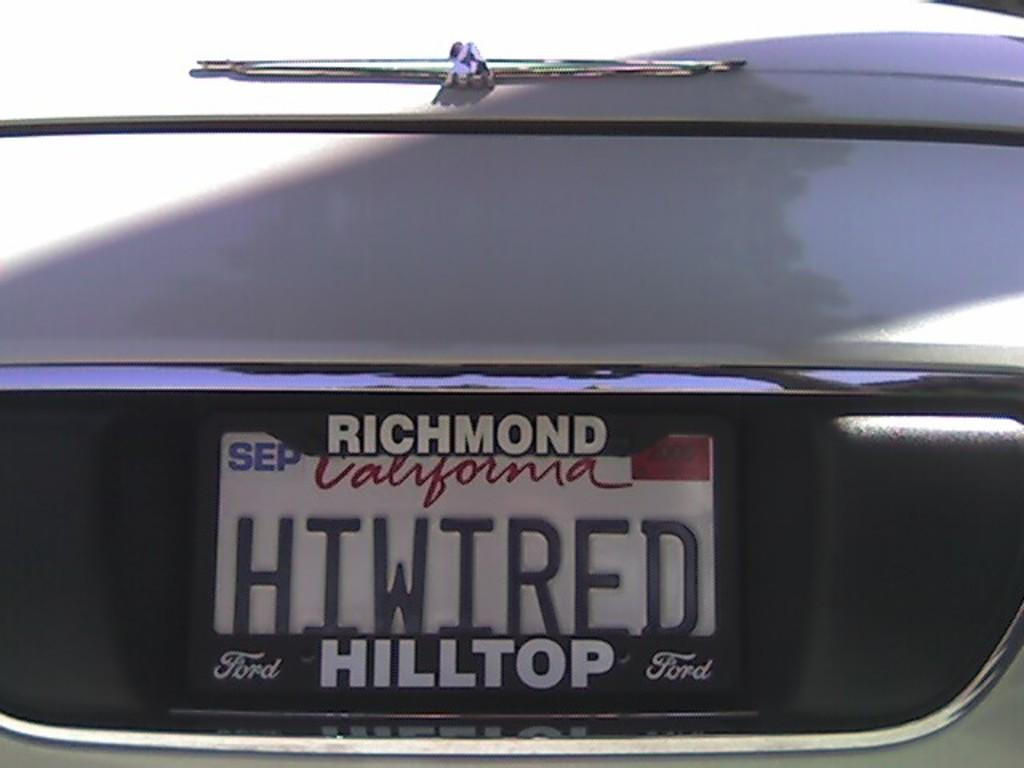What part of the car is visible in the image? The image shows the backside part of a car. Is there any identification on the car? Yes, the car has a number plate. Where was the image taken? The location mentioned is HIWIRE hilltop in Richmond, California. What color is the car? The car is white in color. Are there any men or beggars visible in the image? No, there are no men or beggars present in the image; it only shows the backside part of a car. Is there a swing in the image? No, there is no swing present in the image. 